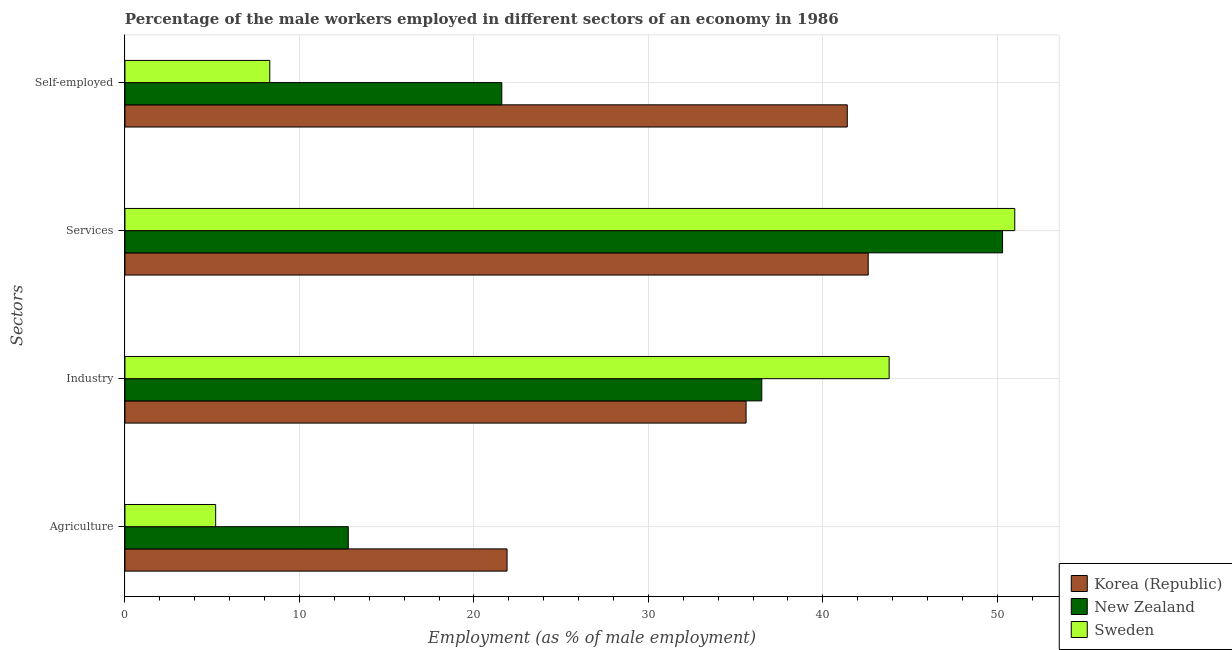How many different coloured bars are there?
Provide a short and direct response. 3. How many groups of bars are there?
Keep it short and to the point. 4. Are the number of bars per tick equal to the number of legend labels?
Your answer should be compact. Yes. What is the label of the 3rd group of bars from the top?
Ensure brevity in your answer.  Industry. What is the percentage of self employed male workers in Korea (Republic)?
Offer a very short reply. 41.4. Across all countries, what is the maximum percentage of self employed male workers?
Give a very brief answer. 41.4. Across all countries, what is the minimum percentage of male workers in services?
Provide a succinct answer. 42.6. What is the total percentage of male workers in agriculture in the graph?
Keep it short and to the point. 39.9. What is the difference between the percentage of male workers in agriculture in Sweden and that in New Zealand?
Provide a short and direct response. -7.6. What is the difference between the percentage of male workers in agriculture in New Zealand and the percentage of male workers in industry in Sweden?
Offer a terse response. -31. What is the average percentage of male workers in agriculture per country?
Offer a terse response. 13.3. What is the difference between the percentage of male workers in agriculture and percentage of self employed male workers in Sweden?
Your answer should be very brief. -3.1. In how many countries, is the percentage of male workers in industry greater than 28 %?
Provide a short and direct response. 3. What is the ratio of the percentage of male workers in industry in Sweden to that in New Zealand?
Your answer should be compact. 1.2. Is the percentage of male workers in industry in Korea (Republic) less than that in New Zealand?
Keep it short and to the point. Yes. Is the difference between the percentage of self employed male workers in Korea (Republic) and Sweden greater than the difference between the percentage of male workers in industry in Korea (Republic) and Sweden?
Give a very brief answer. Yes. What is the difference between the highest and the second highest percentage of self employed male workers?
Provide a succinct answer. 19.8. What is the difference between the highest and the lowest percentage of self employed male workers?
Offer a very short reply. 33.1. Is the sum of the percentage of male workers in agriculture in Korea (Republic) and New Zealand greater than the maximum percentage of male workers in industry across all countries?
Your response must be concise. No. Is it the case that in every country, the sum of the percentage of male workers in agriculture and percentage of male workers in industry is greater than the sum of percentage of self employed male workers and percentage of male workers in services?
Give a very brief answer. No. What does the 2nd bar from the top in Services represents?
Give a very brief answer. New Zealand. What does the 2nd bar from the bottom in Agriculture represents?
Make the answer very short. New Zealand. Is it the case that in every country, the sum of the percentage of male workers in agriculture and percentage of male workers in industry is greater than the percentage of male workers in services?
Provide a short and direct response. No. Are all the bars in the graph horizontal?
Your answer should be compact. Yes. How many countries are there in the graph?
Give a very brief answer. 3. What is the difference between two consecutive major ticks on the X-axis?
Give a very brief answer. 10. How many legend labels are there?
Your answer should be compact. 3. What is the title of the graph?
Provide a succinct answer. Percentage of the male workers employed in different sectors of an economy in 1986. What is the label or title of the X-axis?
Offer a terse response. Employment (as % of male employment). What is the label or title of the Y-axis?
Your response must be concise. Sectors. What is the Employment (as % of male employment) in Korea (Republic) in Agriculture?
Your answer should be compact. 21.9. What is the Employment (as % of male employment) of New Zealand in Agriculture?
Provide a short and direct response. 12.8. What is the Employment (as % of male employment) in Sweden in Agriculture?
Provide a succinct answer. 5.2. What is the Employment (as % of male employment) in Korea (Republic) in Industry?
Give a very brief answer. 35.6. What is the Employment (as % of male employment) in New Zealand in Industry?
Your response must be concise. 36.5. What is the Employment (as % of male employment) of Sweden in Industry?
Provide a succinct answer. 43.8. What is the Employment (as % of male employment) of Korea (Republic) in Services?
Make the answer very short. 42.6. What is the Employment (as % of male employment) in New Zealand in Services?
Offer a very short reply. 50.3. What is the Employment (as % of male employment) of Sweden in Services?
Your answer should be very brief. 51. What is the Employment (as % of male employment) of Korea (Republic) in Self-employed?
Offer a very short reply. 41.4. What is the Employment (as % of male employment) of New Zealand in Self-employed?
Give a very brief answer. 21.6. What is the Employment (as % of male employment) of Sweden in Self-employed?
Offer a terse response. 8.3. Across all Sectors, what is the maximum Employment (as % of male employment) in Korea (Republic)?
Ensure brevity in your answer.  42.6. Across all Sectors, what is the maximum Employment (as % of male employment) in New Zealand?
Provide a short and direct response. 50.3. Across all Sectors, what is the maximum Employment (as % of male employment) of Sweden?
Your response must be concise. 51. Across all Sectors, what is the minimum Employment (as % of male employment) in Korea (Republic)?
Your response must be concise. 21.9. Across all Sectors, what is the minimum Employment (as % of male employment) in New Zealand?
Provide a succinct answer. 12.8. Across all Sectors, what is the minimum Employment (as % of male employment) of Sweden?
Your answer should be very brief. 5.2. What is the total Employment (as % of male employment) in Korea (Republic) in the graph?
Give a very brief answer. 141.5. What is the total Employment (as % of male employment) in New Zealand in the graph?
Offer a very short reply. 121.2. What is the total Employment (as % of male employment) of Sweden in the graph?
Give a very brief answer. 108.3. What is the difference between the Employment (as % of male employment) of Korea (Republic) in Agriculture and that in Industry?
Provide a short and direct response. -13.7. What is the difference between the Employment (as % of male employment) of New Zealand in Agriculture and that in Industry?
Provide a succinct answer. -23.7. What is the difference between the Employment (as % of male employment) of Sweden in Agriculture and that in Industry?
Give a very brief answer. -38.6. What is the difference between the Employment (as % of male employment) in Korea (Republic) in Agriculture and that in Services?
Your answer should be compact. -20.7. What is the difference between the Employment (as % of male employment) in New Zealand in Agriculture and that in Services?
Provide a succinct answer. -37.5. What is the difference between the Employment (as % of male employment) of Sweden in Agriculture and that in Services?
Your response must be concise. -45.8. What is the difference between the Employment (as % of male employment) of Korea (Republic) in Agriculture and that in Self-employed?
Provide a succinct answer. -19.5. What is the difference between the Employment (as % of male employment) of Sweden in Agriculture and that in Self-employed?
Offer a terse response. -3.1. What is the difference between the Employment (as % of male employment) in Korea (Republic) in Industry and that in Services?
Your answer should be compact. -7. What is the difference between the Employment (as % of male employment) of New Zealand in Industry and that in Services?
Your response must be concise. -13.8. What is the difference between the Employment (as % of male employment) in Korea (Republic) in Industry and that in Self-employed?
Make the answer very short. -5.8. What is the difference between the Employment (as % of male employment) in Sweden in Industry and that in Self-employed?
Ensure brevity in your answer.  35.5. What is the difference between the Employment (as % of male employment) of New Zealand in Services and that in Self-employed?
Ensure brevity in your answer.  28.7. What is the difference between the Employment (as % of male employment) in Sweden in Services and that in Self-employed?
Your answer should be very brief. 42.7. What is the difference between the Employment (as % of male employment) in Korea (Republic) in Agriculture and the Employment (as % of male employment) in New Zealand in Industry?
Offer a terse response. -14.6. What is the difference between the Employment (as % of male employment) of Korea (Republic) in Agriculture and the Employment (as % of male employment) of Sweden in Industry?
Your answer should be compact. -21.9. What is the difference between the Employment (as % of male employment) in New Zealand in Agriculture and the Employment (as % of male employment) in Sweden in Industry?
Your answer should be very brief. -31. What is the difference between the Employment (as % of male employment) of Korea (Republic) in Agriculture and the Employment (as % of male employment) of New Zealand in Services?
Provide a short and direct response. -28.4. What is the difference between the Employment (as % of male employment) of Korea (Republic) in Agriculture and the Employment (as % of male employment) of Sweden in Services?
Make the answer very short. -29.1. What is the difference between the Employment (as % of male employment) in New Zealand in Agriculture and the Employment (as % of male employment) in Sweden in Services?
Provide a succinct answer. -38.2. What is the difference between the Employment (as % of male employment) in Korea (Republic) in Agriculture and the Employment (as % of male employment) in New Zealand in Self-employed?
Make the answer very short. 0.3. What is the difference between the Employment (as % of male employment) of Korea (Republic) in Agriculture and the Employment (as % of male employment) of Sweden in Self-employed?
Your answer should be compact. 13.6. What is the difference between the Employment (as % of male employment) in New Zealand in Agriculture and the Employment (as % of male employment) in Sweden in Self-employed?
Make the answer very short. 4.5. What is the difference between the Employment (as % of male employment) of Korea (Republic) in Industry and the Employment (as % of male employment) of New Zealand in Services?
Your response must be concise. -14.7. What is the difference between the Employment (as % of male employment) of Korea (Republic) in Industry and the Employment (as % of male employment) of Sweden in Services?
Provide a succinct answer. -15.4. What is the difference between the Employment (as % of male employment) of Korea (Republic) in Industry and the Employment (as % of male employment) of Sweden in Self-employed?
Give a very brief answer. 27.3. What is the difference between the Employment (as % of male employment) in New Zealand in Industry and the Employment (as % of male employment) in Sweden in Self-employed?
Provide a succinct answer. 28.2. What is the difference between the Employment (as % of male employment) of Korea (Republic) in Services and the Employment (as % of male employment) of Sweden in Self-employed?
Offer a terse response. 34.3. What is the average Employment (as % of male employment) in Korea (Republic) per Sectors?
Make the answer very short. 35.38. What is the average Employment (as % of male employment) of New Zealand per Sectors?
Offer a very short reply. 30.3. What is the average Employment (as % of male employment) of Sweden per Sectors?
Keep it short and to the point. 27.07. What is the difference between the Employment (as % of male employment) of Korea (Republic) and Employment (as % of male employment) of New Zealand in Agriculture?
Give a very brief answer. 9.1. What is the difference between the Employment (as % of male employment) in Korea (Republic) and Employment (as % of male employment) in Sweden in Industry?
Your answer should be compact. -8.2. What is the difference between the Employment (as % of male employment) in New Zealand and Employment (as % of male employment) in Sweden in Industry?
Keep it short and to the point. -7.3. What is the difference between the Employment (as % of male employment) of Korea (Republic) and Employment (as % of male employment) of Sweden in Services?
Keep it short and to the point. -8.4. What is the difference between the Employment (as % of male employment) of New Zealand and Employment (as % of male employment) of Sweden in Services?
Provide a short and direct response. -0.7. What is the difference between the Employment (as % of male employment) of Korea (Republic) and Employment (as % of male employment) of New Zealand in Self-employed?
Your response must be concise. 19.8. What is the difference between the Employment (as % of male employment) in Korea (Republic) and Employment (as % of male employment) in Sweden in Self-employed?
Provide a short and direct response. 33.1. What is the ratio of the Employment (as % of male employment) in Korea (Republic) in Agriculture to that in Industry?
Offer a terse response. 0.62. What is the ratio of the Employment (as % of male employment) of New Zealand in Agriculture to that in Industry?
Offer a terse response. 0.35. What is the ratio of the Employment (as % of male employment) in Sweden in Agriculture to that in Industry?
Keep it short and to the point. 0.12. What is the ratio of the Employment (as % of male employment) in Korea (Republic) in Agriculture to that in Services?
Provide a succinct answer. 0.51. What is the ratio of the Employment (as % of male employment) of New Zealand in Agriculture to that in Services?
Ensure brevity in your answer.  0.25. What is the ratio of the Employment (as % of male employment) in Sweden in Agriculture to that in Services?
Your answer should be compact. 0.1. What is the ratio of the Employment (as % of male employment) in Korea (Republic) in Agriculture to that in Self-employed?
Your answer should be very brief. 0.53. What is the ratio of the Employment (as % of male employment) in New Zealand in Agriculture to that in Self-employed?
Provide a short and direct response. 0.59. What is the ratio of the Employment (as % of male employment) of Sweden in Agriculture to that in Self-employed?
Give a very brief answer. 0.63. What is the ratio of the Employment (as % of male employment) of Korea (Republic) in Industry to that in Services?
Keep it short and to the point. 0.84. What is the ratio of the Employment (as % of male employment) in New Zealand in Industry to that in Services?
Ensure brevity in your answer.  0.73. What is the ratio of the Employment (as % of male employment) of Sweden in Industry to that in Services?
Provide a short and direct response. 0.86. What is the ratio of the Employment (as % of male employment) of Korea (Republic) in Industry to that in Self-employed?
Provide a short and direct response. 0.86. What is the ratio of the Employment (as % of male employment) in New Zealand in Industry to that in Self-employed?
Provide a short and direct response. 1.69. What is the ratio of the Employment (as % of male employment) of Sweden in Industry to that in Self-employed?
Keep it short and to the point. 5.28. What is the ratio of the Employment (as % of male employment) of Korea (Republic) in Services to that in Self-employed?
Your answer should be very brief. 1.03. What is the ratio of the Employment (as % of male employment) in New Zealand in Services to that in Self-employed?
Offer a terse response. 2.33. What is the ratio of the Employment (as % of male employment) in Sweden in Services to that in Self-employed?
Your answer should be very brief. 6.14. What is the difference between the highest and the second highest Employment (as % of male employment) in Sweden?
Keep it short and to the point. 7.2. What is the difference between the highest and the lowest Employment (as % of male employment) in Korea (Republic)?
Offer a terse response. 20.7. What is the difference between the highest and the lowest Employment (as % of male employment) of New Zealand?
Ensure brevity in your answer.  37.5. What is the difference between the highest and the lowest Employment (as % of male employment) of Sweden?
Give a very brief answer. 45.8. 